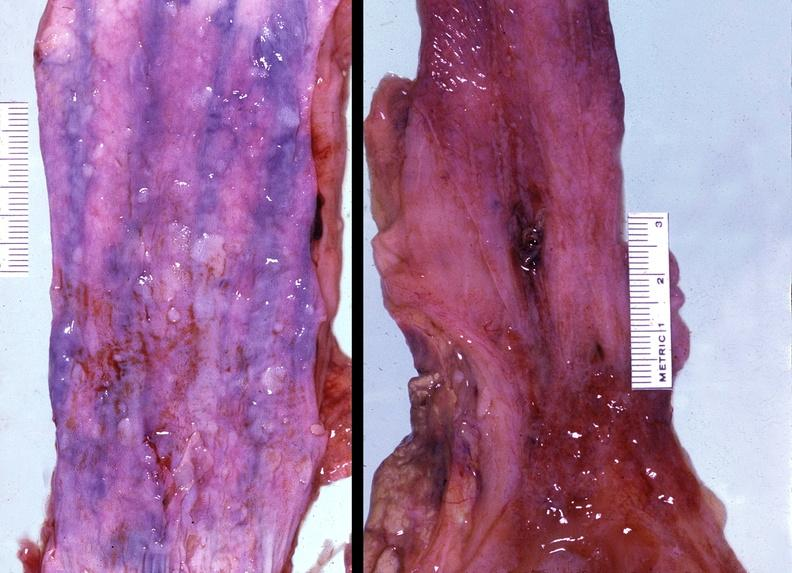does this image show esophagus, varices?
Answer the question using a single word or phrase. Yes 